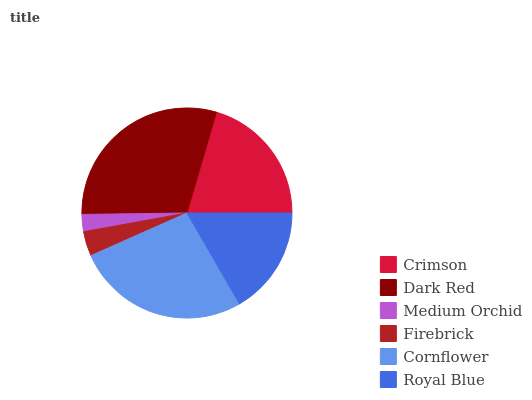Is Medium Orchid the minimum?
Answer yes or no. Yes. Is Dark Red the maximum?
Answer yes or no. Yes. Is Dark Red the minimum?
Answer yes or no. No. Is Medium Orchid the maximum?
Answer yes or no. No. Is Dark Red greater than Medium Orchid?
Answer yes or no. Yes. Is Medium Orchid less than Dark Red?
Answer yes or no. Yes. Is Medium Orchid greater than Dark Red?
Answer yes or no. No. Is Dark Red less than Medium Orchid?
Answer yes or no. No. Is Crimson the high median?
Answer yes or no. Yes. Is Royal Blue the low median?
Answer yes or no. Yes. Is Cornflower the high median?
Answer yes or no. No. Is Dark Red the low median?
Answer yes or no. No. 